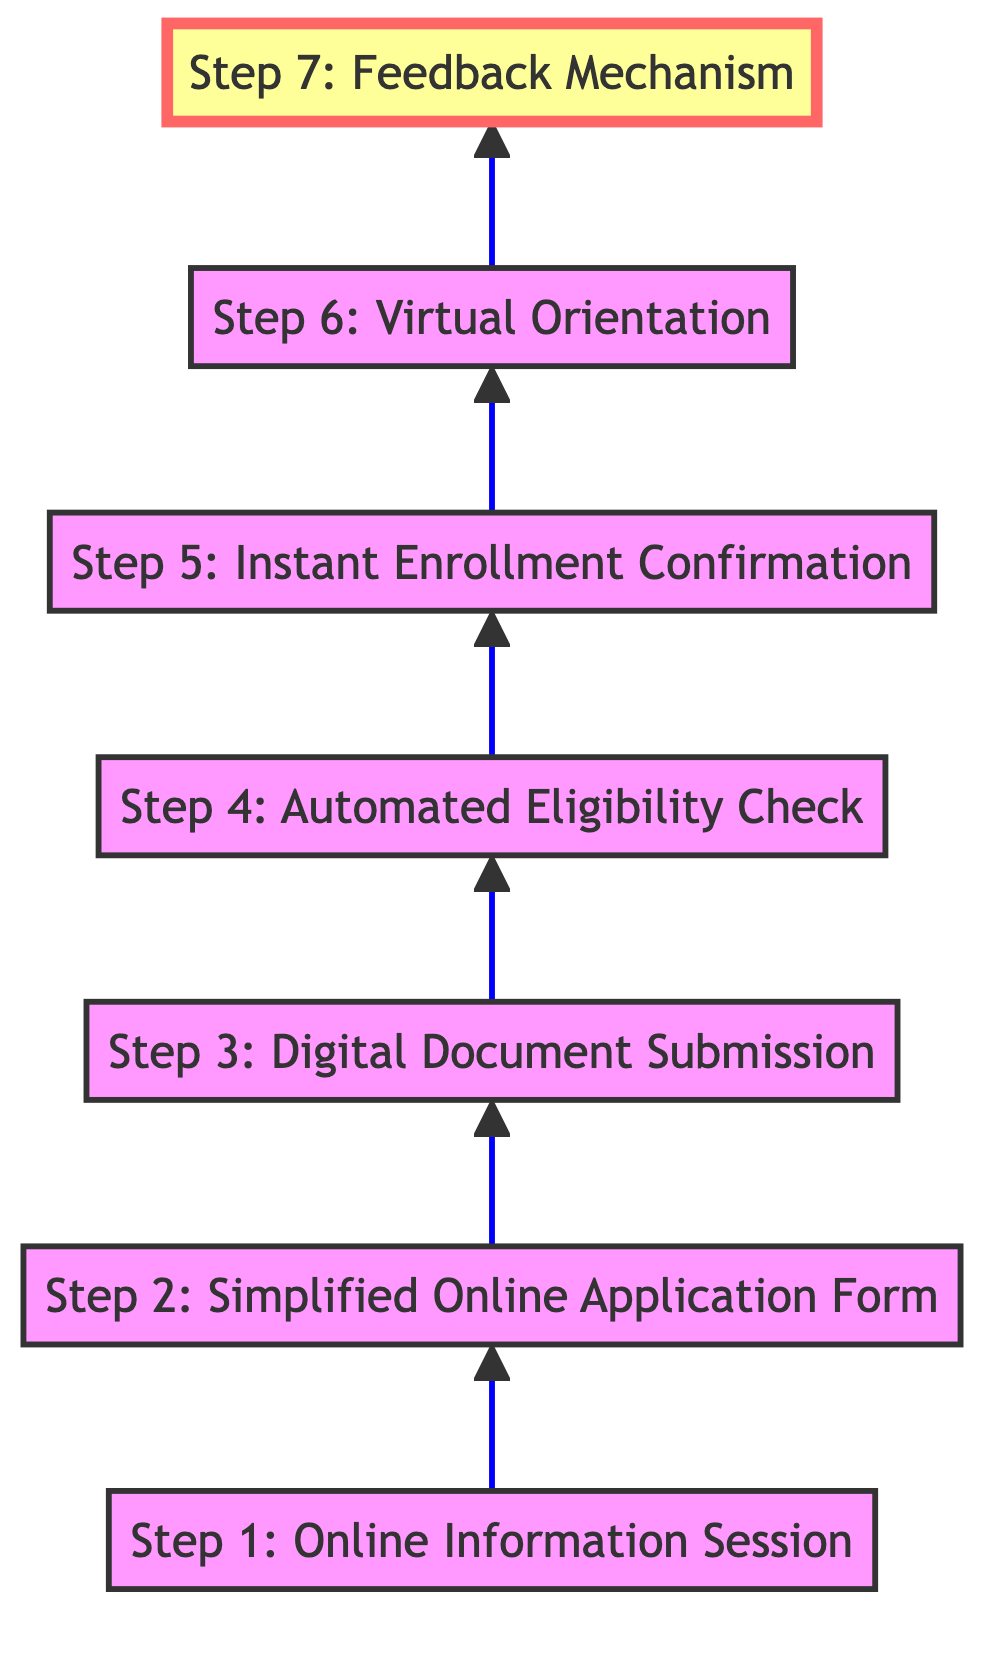What is the last step in the enrollment procedure? The last step in the flow chart is the "Feedback Mechanism." This is determined by examining the nodes from the bottom to the top. The flow leads to seven steps, and the last one listed is "Feedback Mechanism."
Answer: Feedback Mechanism How many steps are involved in the enrollment process? The flow chart shows a total of seven steps, as we can count each of the listed stages connected by arrows moving from the bottom to the top.
Answer: Seven steps What step comes immediately before "Digital Document Submission"? The step that comes immediately before "Digital Document Submission" is "Simplified Online Application Form." By tracing the flow, we see that the arrow points from "Simplified Online Application Form" to "Digital Document Submission."
Answer: Simplified Online Application Form Which step includes sending confirmation emails? The step that includes sending confirmation emails is "Instant Enrollment Confirmation." This is clearly labeled in the flow chart, and it follows "Automated Eligibility Check."
Answer: Instant Enrollment Confirmation What is the function of the "Automated Eligibility Check"? The "Automated Eligibility Check" uses software to automatically verify applicant eligibility based on predefined criteria. This is indicated directly in the node description in the flow chart.
Answer: Verify eligibility How many steps involve direct communication with students? There are three steps involving direct communication: "Online Information Session," "Instant Enrollment Confirmation," and "Virtual Orientation." These steps specifically detail interactions with students, either through informative sessions or confirmations.
Answer: Three steps Which step highlights continuous process improvement? The step that highlights continuous process improvement is "Feedback Mechanism." This is emphasized in the description, which explains that it collects suggestions from applicants.
Answer: Feedback Mechanism What is the first step in the enrollment procedure? The first step in the flow chart is "Online Information Session." This is the starting point for the entire enrollment process, indicated by its position at the bottom of the diagram.
Answer: Online Information Session What role does "Digital Document Submission" play in the process? "Digital Document Submission" allows students to upload necessary documents directly through the online portal, facilitating easier collection of required documentation for enrollment. This information is detailed in the step's description.
Answer: Upload documents 